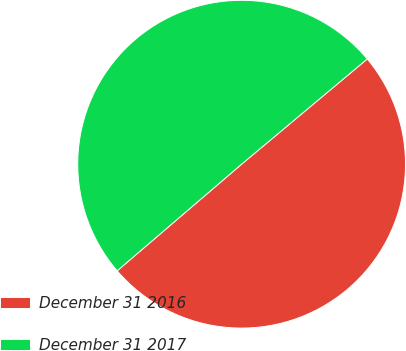<chart> <loc_0><loc_0><loc_500><loc_500><pie_chart><fcel>December 31 2016<fcel>December 31 2017<nl><fcel>49.82%<fcel>50.18%<nl></chart> 